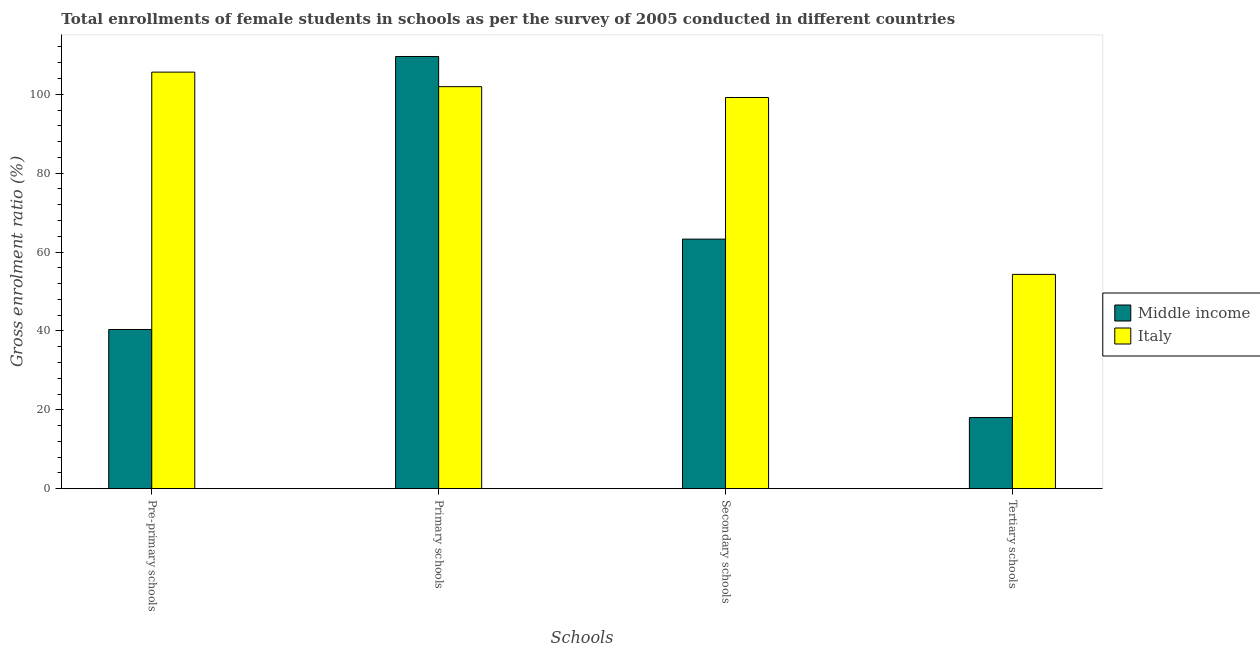How many different coloured bars are there?
Offer a very short reply. 2. How many groups of bars are there?
Make the answer very short. 4. Are the number of bars per tick equal to the number of legend labels?
Your answer should be very brief. Yes. What is the label of the 1st group of bars from the left?
Your response must be concise. Pre-primary schools. What is the gross enrolment ratio(female) in pre-primary schools in Middle income?
Make the answer very short. 40.36. Across all countries, what is the maximum gross enrolment ratio(female) in secondary schools?
Give a very brief answer. 99.17. Across all countries, what is the minimum gross enrolment ratio(female) in pre-primary schools?
Your answer should be very brief. 40.36. In which country was the gross enrolment ratio(female) in primary schools maximum?
Your answer should be compact. Middle income. What is the total gross enrolment ratio(female) in tertiary schools in the graph?
Ensure brevity in your answer.  72.37. What is the difference between the gross enrolment ratio(female) in pre-primary schools in Italy and that in Middle income?
Make the answer very short. 65.26. What is the difference between the gross enrolment ratio(female) in tertiary schools in Middle income and the gross enrolment ratio(female) in primary schools in Italy?
Your answer should be compact. -83.9. What is the average gross enrolment ratio(female) in tertiary schools per country?
Ensure brevity in your answer.  36.18. What is the difference between the gross enrolment ratio(female) in pre-primary schools and gross enrolment ratio(female) in tertiary schools in Middle income?
Offer a very short reply. 22.33. What is the ratio of the gross enrolment ratio(female) in primary schools in Middle income to that in Italy?
Give a very brief answer. 1.08. What is the difference between the highest and the second highest gross enrolment ratio(female) in secondary schools?
Your response must be concise. 35.9. What is the difference between the highest and the lowest gross enrolment ratio(female) in secondary schools?
Give a very brief answer. 35.9. In how many countries, is the gross enrolment ratio(female) in pre-primary schools greater than the average gross enrolment ratio(female) in pre-primary schools taken over all countries?
Your response must be concise. 1. Is the sum of the gross enrolment ratio(female) in pre-primary schools in Italy and Middle income greater than the maximum gross enrolment ratio(female) in secondary schools across all countries?
Provide a succinct answer. Yes. Is it the case that in every country, the sum of the gross enrolment ratio(female) in secondary schools and gross enrolment ratio(female) in pre-primary schools is greater than the sum of gross enrolment ratio(female) in primary schools and gross enrolment ratio(female) in tertiary schools?
Provide a succinct answer. Yes. What does the 1st bar from the right in Tertiary schools represents?
Your answer should be very brief. Italy. Does the graph contain grids?
Give a very brief answer. No. How many legend labels are there?
Your answer should be compact. 2. What is the title of the graph?
Your answer should be very brief. Total enrollments of female students in schools as per the survey of 2005 conducted in different countries. Does "Suriname" appear as one of the legend labels in the graph?
Your answer should be compact. No. What is the label or title of the X-axis?
Make the answer very short. Schools. What is the Gross enrolment ratio (%) of Middle income in Pre-primary schools?
Your answer should be very brief. 40.36. What is the Gross enrolment ratio (%) of Italy in Pre-primary schools?
Provide a succinct answer. 105.62. What is the Gross enrolment ratio (%) in Middle income in Primary schools?
Ensure brevity in your answer.  109.58. What is the Gross enrolment ratio (%) in Italy in Primary schools?
Provide a short and direct response. 101.93. What is the Gross enrolment ratio (%) in Middle income in Secondary schools?
Offer a terse response. 63.27. What is the Gross enrolment ratio (%) of Italy in Secondary schools?
Ensure brevity in your answer.  99.17. What is the Gross enrolment ratio (%) of Middle income in Tertiary schools?
Your response must be concise. 18.03. What is the Gross enrolment ratio (%) in Italy in Tertiary schools?
Give a very brief answer. 54.33. Across all Schools, what is the maximum Gross enrolment ratio (%) in Middle income?
Ensure brevity in your answer.  109.58. Across all Schools, what is the maximum Gross enrolment ratio (%) of Italy?
Provide a succinct answer. 105.62. Across all Schools, what is the minimum Gross enrolment ratio (%) in Middle income?
Offer a very short reply. 18.03. Across all Schools, what is the minimum Gross enrolment ratio (%) in Italy?
Provide a succinct answer. 54.33. What is the total Gross enrolment ratio (%) in Middle income in the graph?
Your answer should be compact. 231.25. What is the total Gross enrolment ratio (%) of Italy in the graph?
Your response must be concise. 361.05. What is the difference between the Gross enrolment ratio (%) in Middle income in Pre-primary schools and that in Primary schools?
Offer a very short reply. -69.22. What is the difference between the Gross enrolment ratio (%) in Italy in Pre-primary schools and that in Primary schools?
Your answer should be compact. 3.68. What is the difference between the Gross enrolment ratio (%) of Middle income in Pre-primary schools and that in Secondary schools?
Your answer should be compact. -22.91. What is the difference between the Gross enrolment ratio (%) in Italy in Pre-primary schools and that in Secondary schools?
Keep it short and to the point. 6.44. What is the difference between the Gross enrolment ratio (%) in Middle income in Pre-primary schools and that in Tertiary schools?
Offer a terse response. 22.33. What is the difference between the Gross enrolment ratio (%) of Italy in Pre-primary schools and that in Tertiary schools?
Keep it short and to the point. 51.28. What is the difference between the Gross enrolment ratio (%) in Middle income in Primary schools and that in Secondary schools?
Keep it short and to the point. 46.31. What is the difference between the Gross enrolment ratio (%) of Italy in Primary schools and that in Secondary schools?
Keep it short and to the point. 2.76. What is the difference between the Gross enrolment ratio (%) of Middle income in Primary schools and that in Tertiary schools?
Provide a succinct answer. 91.55. What is the difference between the Gross enrolment ratio (%) in Italy in Primary schools and that in Tertiary schools?
Provide a succinct answer. 47.6. What is the difference between the Gross enrolment ratio (%) of Middle income in Secondary schools and that in Tertiary schools?
Ensure brevity in your answer.  45.24. What is the difference between the Gross enrolment ratio (%) in Italy in Secondary schools and that in Tertiary schools?
Give a very brief answer. 44.84. What is the difference between the Gross enrolment ratio (%) in Middle income in Pre-primary schools and the Gross enrolment ratio (%) in Italy in Primary schools?
Your answer should be compact. -61.57. What is the difference between the Gross enrolment ratio (%) of Middle income in Pre-primary schools and the Gross enrolment ratio (%) of Italy in Secondary schools?
Provide a short and direct response. -58.81. What is the difference between the Gross enrolment ratio (%) in Middle income in Pre-primary schools and the Gross enrolment ratio (%) in Italy in Tertiary schools?
Offer a very short reply. -13.97. What is the difference between the Gross enrolment ratio (%) of Middle income in Primary schools and the Gross enrolment ratio (%) of Italy in Secondary schools?
Provide a short and direct response. 10.41. What is the difference between the Gross enrolment ratio (%) of Middle income in Primary schools and the Gross enrolment ratio (%) of Italy in Tertiary schools?
Provide a short and direct response. 55.25. What is the difference between the Gross enrolment ratio (%) of Middle income in Secondary schools and the Gross enrolment ratio (%) of Italy in Tertiary schools?
Keep it short and to the point. 8.94. What is the average Gross enrolment ratio (%) in Middle income per Schools?
Provide a short and direct response. 57.81. What is the average Gross enrolment ratio (%) of Italy per Schools?
Your response must be concise. 90.26. What is the difference between the Gross enrolment ratio (%) in Middle income and Gross enrolment ratio (%) in Italy in Pre-primary schools?
Offer a terse response. -65.26. What is the difference between the Gross enrolment ratio (%) of Middle income and Gross enrolment ratio (%) of Italy in Primary schools?
Provide a succinct answer. 7.65. What is the difference between the Gross enrolment ratio (%) of Middle income and Gross enrolment ratio (%) of Italy in Secondary schools?
Provide a succinct answer. -35.9. What is the difference between the Gross enrolment ratio (%) of Middle income and Gross enrolment ratio (%) of Italy in Tertiary schools?
Your answer should be compact. -36.3. What is the ratio of the Gross enrolment ratio (%) in Middle income in Pre-primary schools to that in Primary schools?
Ensure brevity in your answer.  0.37. What is the ratio of the Gross enrolment ratio (%) of Italy in Pre-primary schools to that in Primary schools?
Your answer should be very brief. 1.04. What is the ratio of the Gross enrolment ratio (%) of Middle income in Pre-primary schools to that in Secondary schools?
Your response must be concise. 0.64. What is the ratio of the Gross enrolment ratio (%) of Italy in Pre-primary schools to that in Secondary schools?
Your answer should be very brief. 1.06. What is the ratio of the Gross enrolment ratio (%) in Middle income in Pre-primary schools to that in Tertiary schools?
Ensure brevity in your answer.  2.24. What is the ratio of the Gross enrolment ratio (%) of Italy in Pre-primary schools to that in Tertiary schools?
Offer a terse response. 1.94. What is the ratio of the Gross enrolment ratio (%) of Middle income in Primary schools to that in Secondary schools?
Ensure brevity in your answer.  1.73. What is the ratio of the Gross enrolment ratio (%) in Italy in Primary schools to that in Secondary schools?
Offer a terse response. 1.03. What is the ratio of the Gross enrolment ratio (%) in Middle income in Primary schools to that in Tertiary schools?
Ensure brevity in your answer.  6.08. What is the ratio of the Gross enrolment ratio (%) in Italy in Primary schools to that in Tertiary schools?
Make the answer very short. 1.88. What is the ratio of the Gross enrolment ratio (%) of Middle income in Secondary schools to that in Tertiary schools?
Provide a succinct answer. 3.51. What is the ratio of the Gross enrolment ratio (%) in Italy in Secondary schools to that in Tertiary schools?
Give a very brief answer. 1.83. What is the difference between the highest and the second highest Gross enrolment ratio (%) of Middle income?
Ensure brevity in your answer.  46.31. What is the difference between the highest and the second highest Gross enrolment ratio (%) in Italy?
Give a very brief answer. 3.68. What is the difference between the highest and the lowest Gross enrolment ratio (%) in Middle income?
Your response must be concise. 91.55. What is the difference between the highest and the lowest Gross enrolment ratio (%) of Italy?
Make the answer very short. 51.28. 